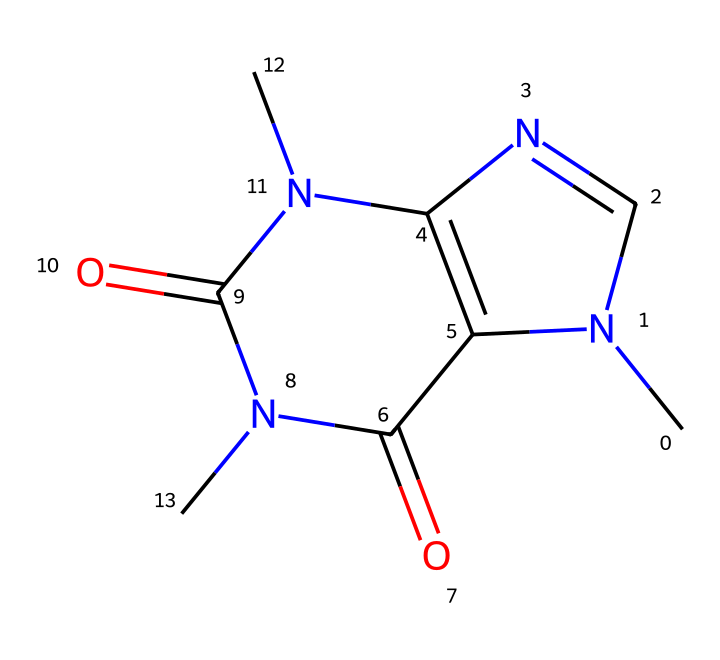What is the molecular formula of caffeine? To determine the molecular formula, identify the elements present in the SMILES representation and count their occurrences. In this case, C (carbon), H (hydrogen), N (nitrogen), and O (oxygen) are present. There are 8 carbons, 10 hydrogens, 4 nitrogens, and 2 oxygens, resulting in the formula C8H10N4O2.
Answer: C8H10N4O2 How many nitrogen atoms are in the caffeine structure? Count the nitrogen (N) atoms present in the SMILES representation. There are 4 occurrences of nitrogen in the structure.
Answer: 4 Is the structure of caffeine aromatic? The structure contains multiple conjugated pi systems involving carbon atoms, leading to delocalized electrons, which is characteristic of aromaticity. Thus, the caffeine structure is considered aromatic.
Answer: yes What type of chemical is caffeine classified as? Caffeine contains nitrogen atoms and has a complex ring structure. It is classified as an alkaloid, which is a class of nitrogen-containing compounds often derived from plants.
Answer: alkaloid How many rings are present in the caffeine structure? Analyze the SMILES representation for cyclic structures. The representation shows two interconnected rings, confirming that there are 2 rings in total.
Answer: 2 